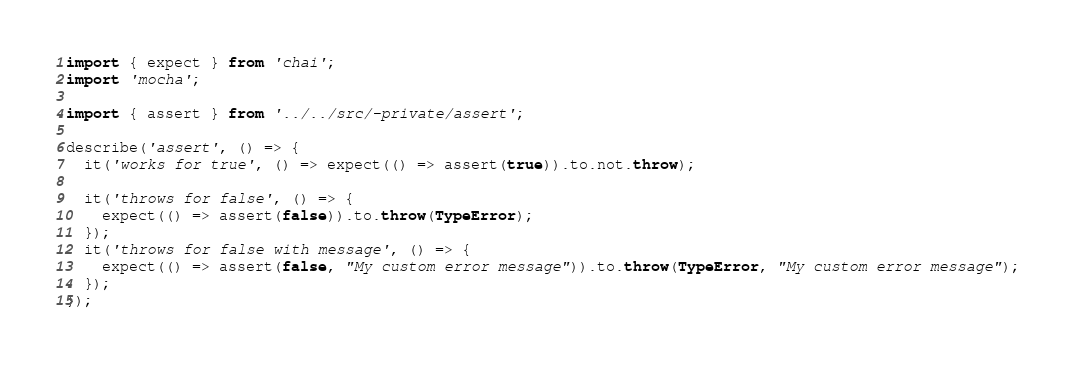Convert code to text. <code><loc_0><loc_0><loc_500><loc_500><_TypeScript_>import { expect } from 'chai';
import 'mocha';

import { assert } from '../../src/-private/assert';

describe('assert', () => {
  it('works for true', () => expect(() => assert(true)).to.not.throw);
  
  it('throws for false', () => {
    expect(() => assert(false)).to.throw(TypeError);
  });
  it('throws for false with message', () => {
    expect(() => assert(false, "My custom error message")).to.throw(TypeError, "My custom error message");
  });
});
</code> 